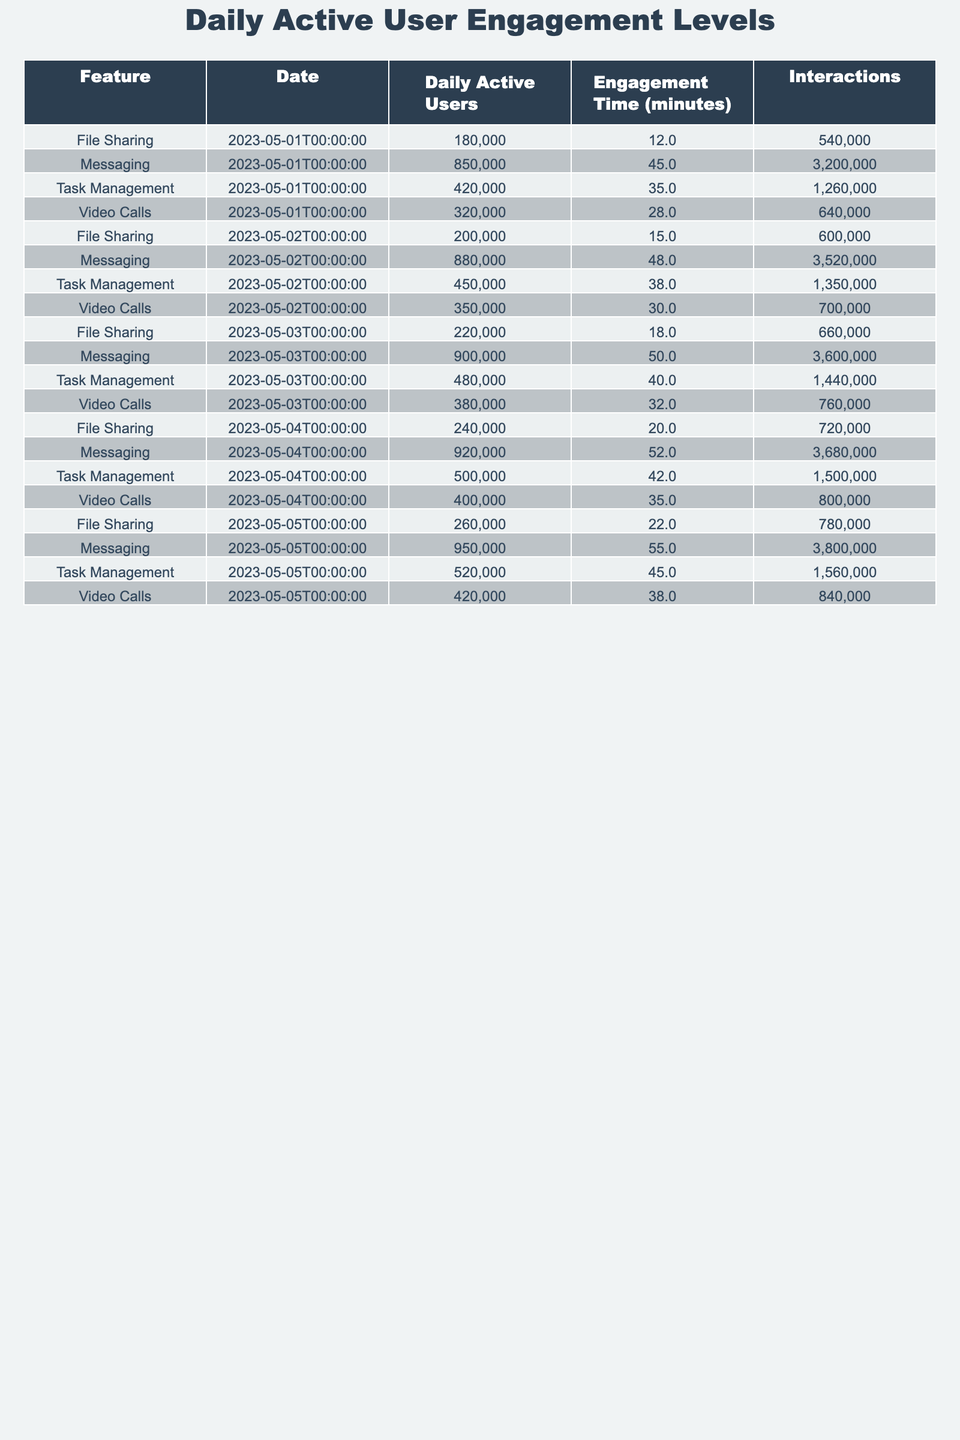What was the highest number of Daily Active Users for the Messaging feature? The highest number in the Daily Active Users column for the Messaging feature is on 2023-05-05 with 950,000 users.
Answer: 950,000 Which app feature had the lowest Engagement Time on May 2, 2023? On May 2, 2023, the File Sharing feature had the lowest Engagement Time of 15 minutes.
Answer: 15 minutes What is the total number of Interactions for Video Calls across the five days? Summing the Interactions for Video Calls gives: 640,000 + 700,000 + 760,000 + 800,000 + 840,000 = 3,740,000.
Answer: 3,740,000 Was there an increase in Daily Active Users for File Sharing from May 1 to May 5, 2023? The Daily Active Users for File Sharing increased from 180,000 on May 1 to 260,000 on May 5, confirming an increase.
Answer: Yes What was the average Engagement Time for Task Management over the five days? Calculating the average: (35 + 38 + 40 + 42 + 45) / 5 = 40.
Answer: 40 minutes On which day did Video Calls have the highest Daily Active Users? Video Calls had the highest Daily Active Users on May 5, 2023, with 420,000 users.
Answer: May 5, 2023 What is the difference in Interactions for Messaging between May 1 and May 5, 2023? Interactions for Messaging on May 1 was 3,200,000 and on May 5 was 3,800,000. The difference is 3,800,000 - 3,200,000 = 600,000.
Answer: 600,000 Which feature consistently had the lowest Daily Active Users throughout the five days? The feature with the lowest Daily Active Users consistently was File Sharing, as it had lower numbers than the others each day.
Answer: File Sharing On what date did Task Management have the highest Engagement Time? Task Management had the highest Engagement Time on May 5, 2023, with 45 minutes.
Answer: May 5, 2023 What is the total Engagement Time across all features for May 3, 2023? Adding Engagement Times for May 3: 50 + 32 + 18 + 40 = 140 minutes.
Answer: 140 minutes Was the average Daily Active Users for Video Calls greater than 350,000 over the five days? The average Daily Active Users for Video Calls is (320,000 + 350,000 + 380,000 + 400,000 + 420,000) / 5 = 354,000, which is greater than 350,000.
Answer: Yes 